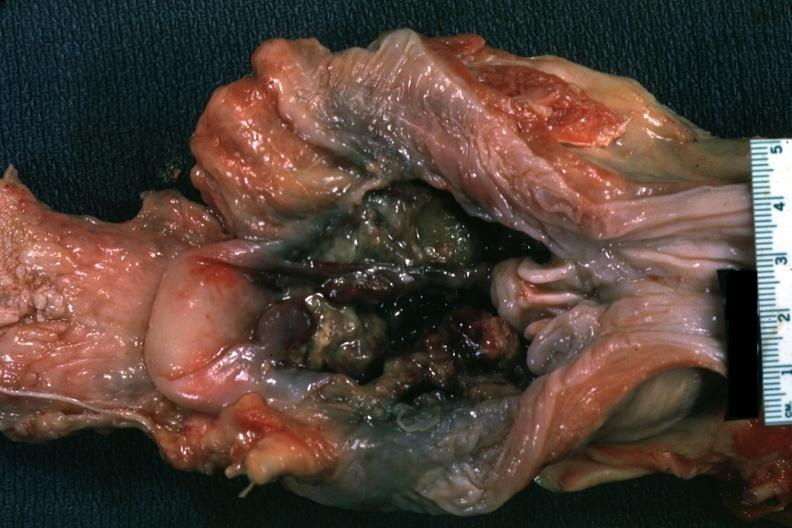what is present?
Answer the question using a single word or phrase. Carcinoma 